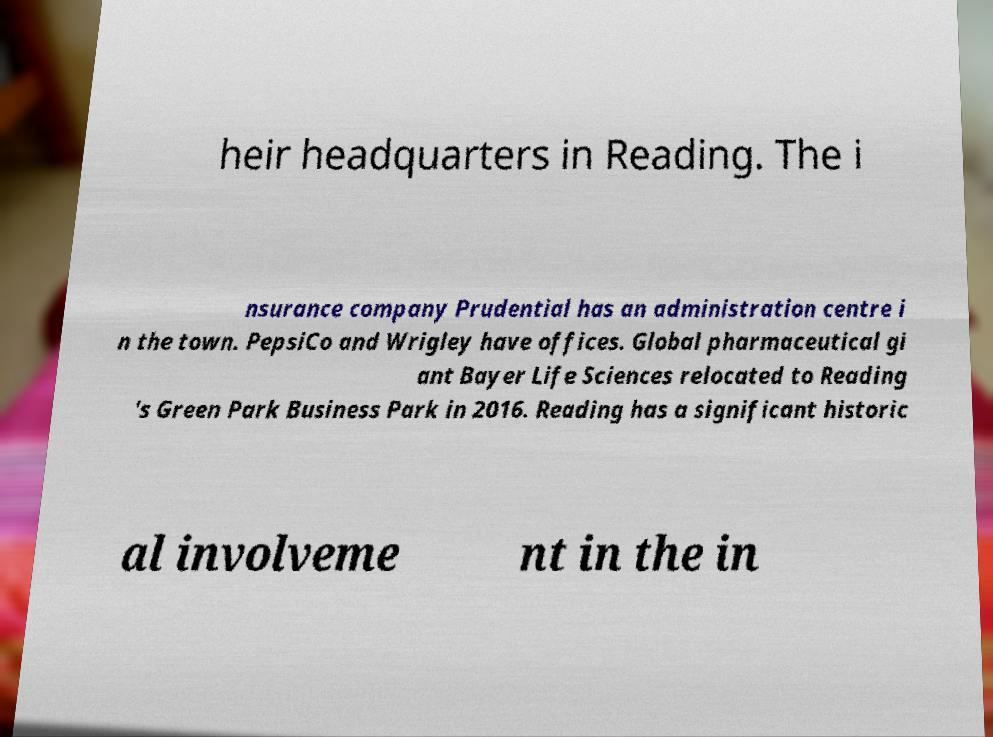What messages or text are displayed in this image? I need them in a readable, typed format. heir headquarters in Reading. The i nsurance company Prudential has an administration centre i n the town. PepsiCo and Wrigley have offices. Global pharmaceutical gi ant Bayer Life Sciences relocated to Reading 's Green Park Business Park in 2016. Reading has a significant historic al involveme nt in the in 